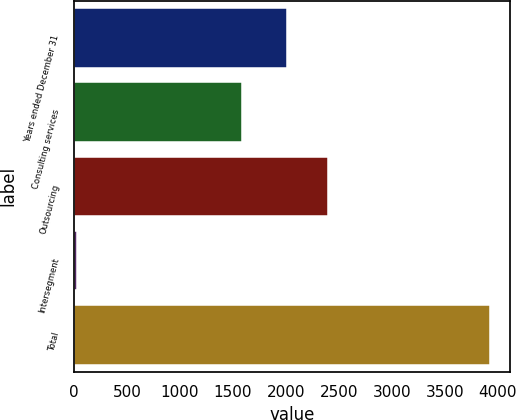<chart> <loc_0><loc_0><loc_500><loc_500><bar_chart><fcel>Years ended December 31<fcel>Consulting services<fcel>Outsourcing<fcel>Intersegment<fcel>Total<nl><fcel>2012<fcel>1585<fcel>2401.3<fcel>32<fcel>3925<nl></chart> 